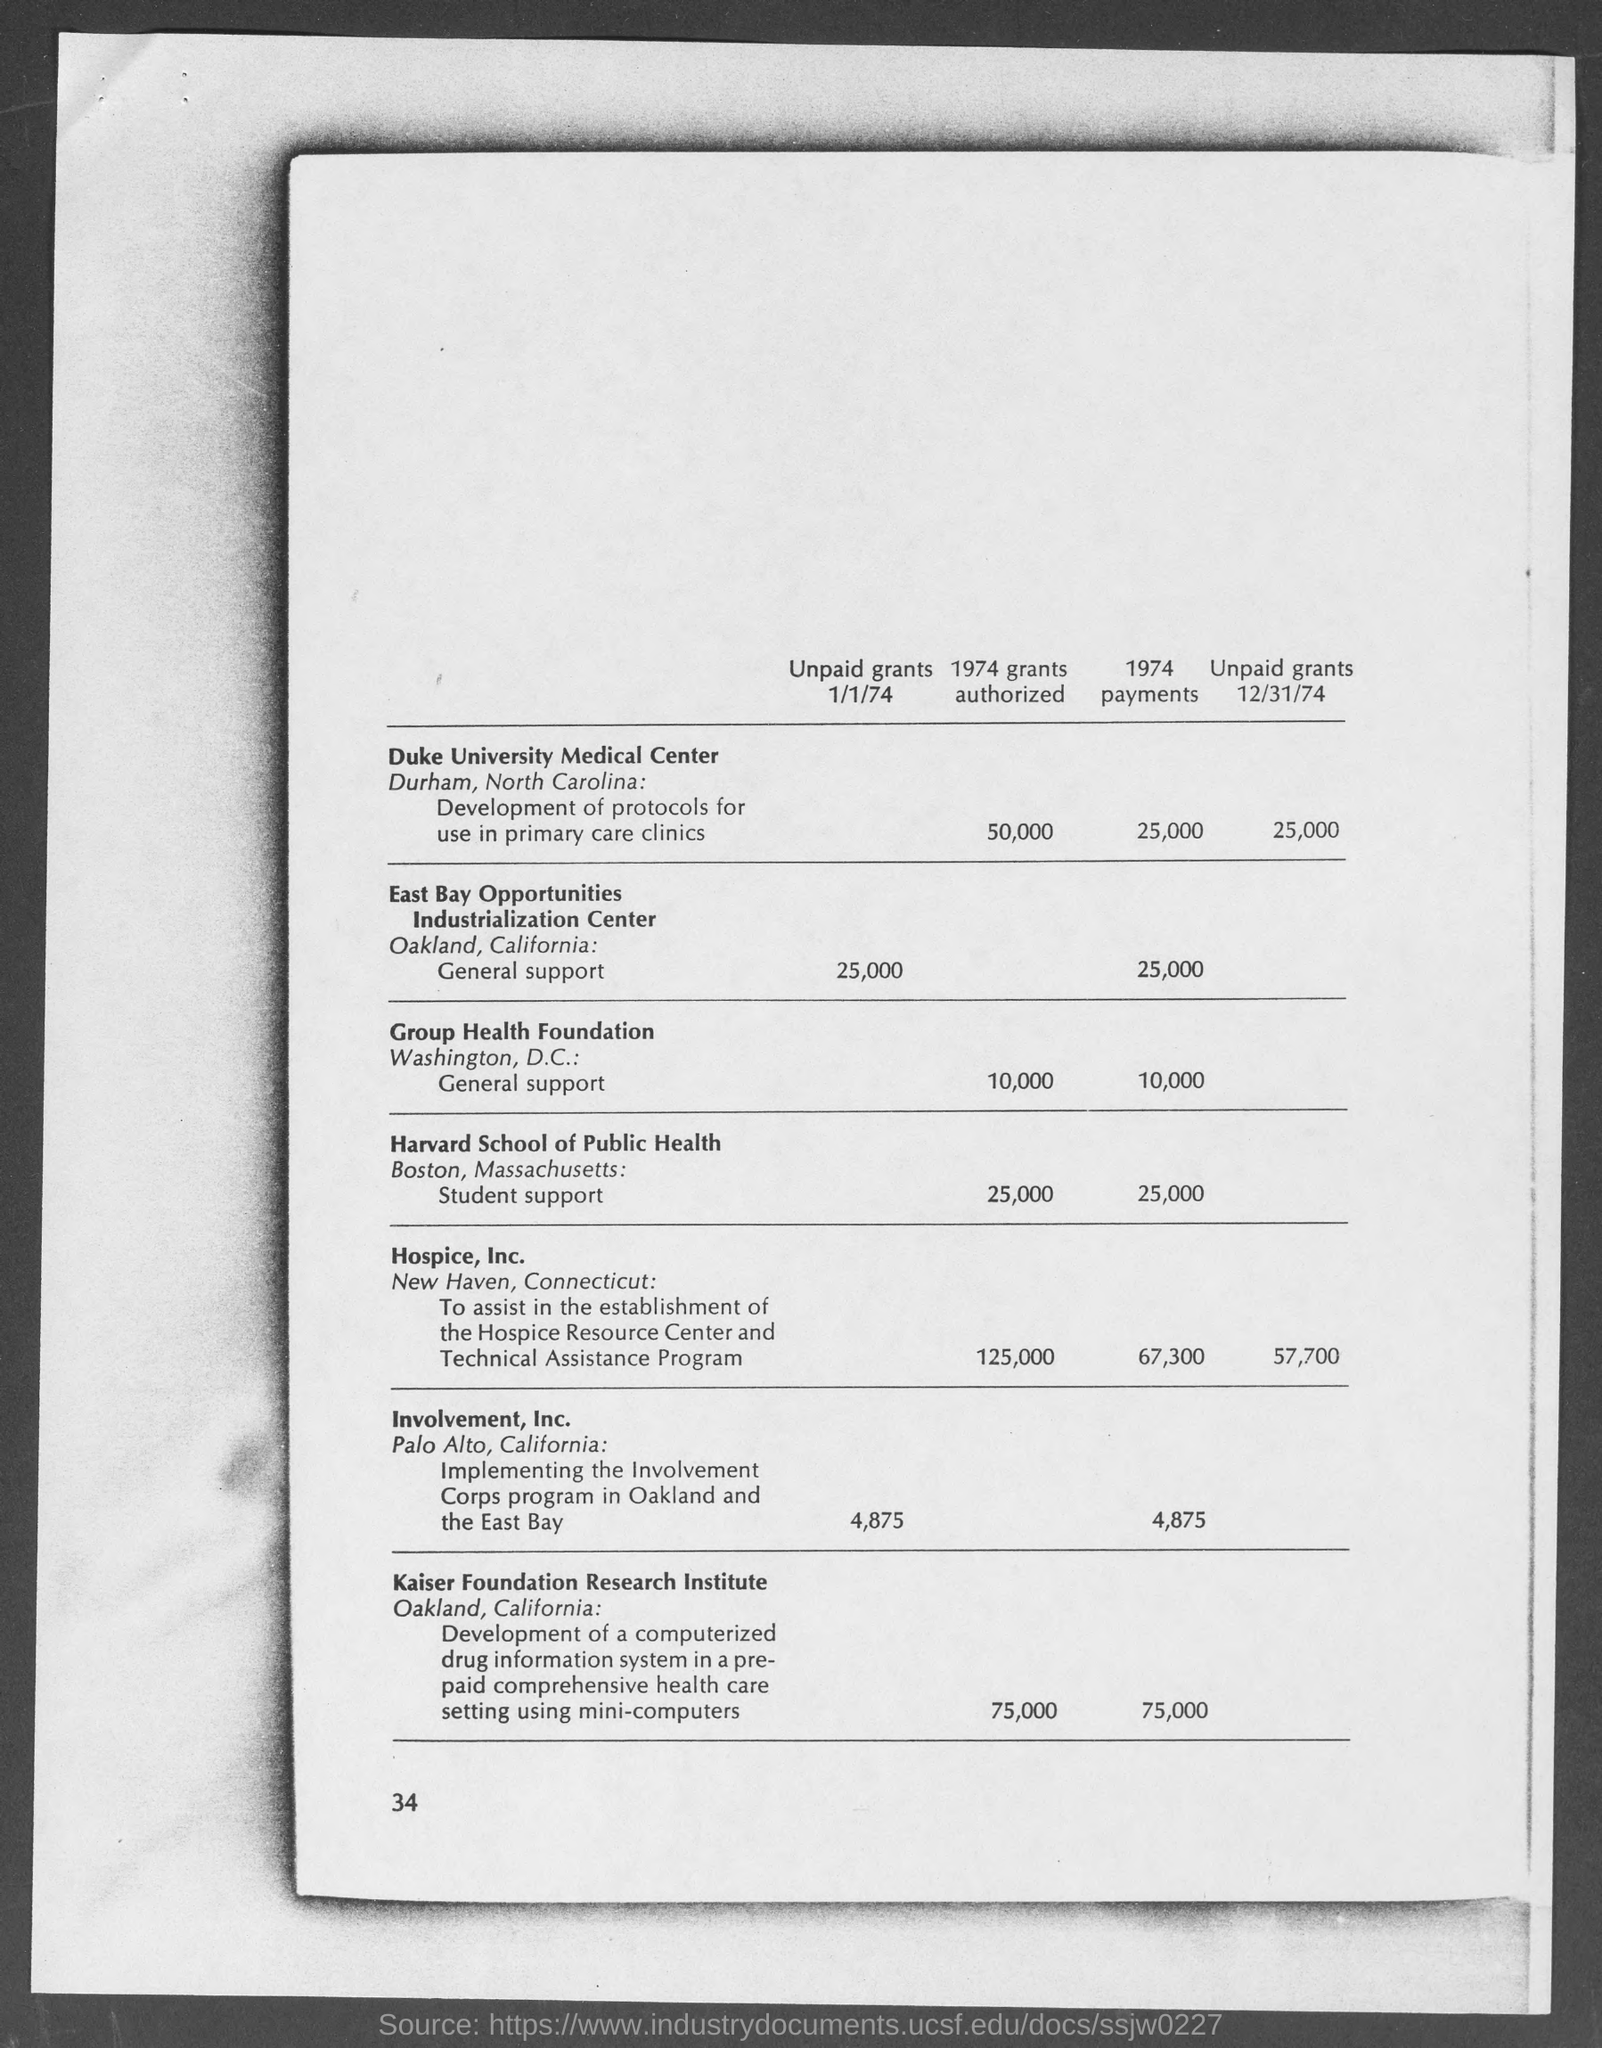What is the number at bottom-left corner of the page ?
Offer a terse response. 34. In which city is duke university medical center at?
Ensure brevity in your answer.  Durham. In which city is east bay opportunities industrialization center at?
Keep it short and to the point. Oakland. In which city is harvard school of public health at?
Provide a succinct answer. Boston. In which city is hospice, inc. at ?
Your answer should be very brief. New Haven. In which city is involvement, inc at?
Your answer should be compact. Palo Alto. In which city is kaiser foundation research institute at ?
Give a very brief answer. Oakland. 